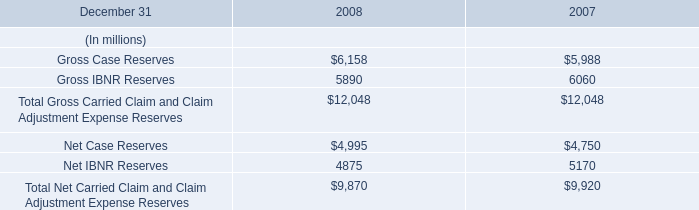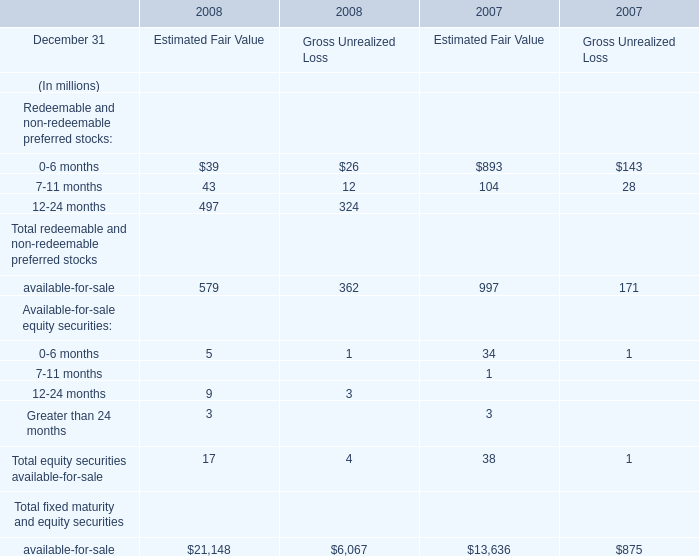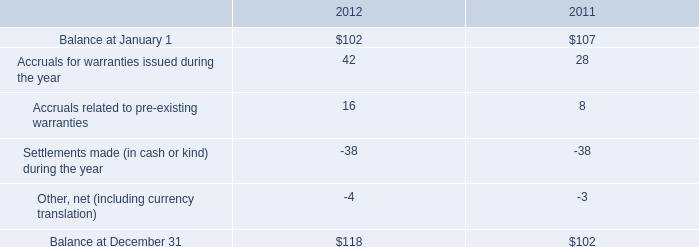What's the total amount of the Gross Case Reserves and Gross IBNR Reserves for Estimated Fair Value in the years where 0-6 months is greater than 100? (in million) 
Computations: (5988 + 6060)
Answer: 12048.0. 